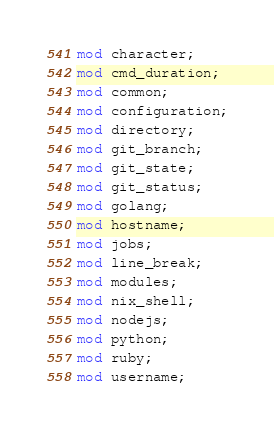<code> <loc_0><loc_0><loc_500><loc_500><_Rust_>mod character;
mod cmd_duration;
mod common;
mod configuration;
mod directory;
mod git_branch;
mod git_state;
mod git_status;
mod golang;
mod hostname;
mod jobs;
mod line_break;
mod modules;
mod nix_shell;
mod nodejs;
mod python;
mod ruby;
mod username;
</code> 